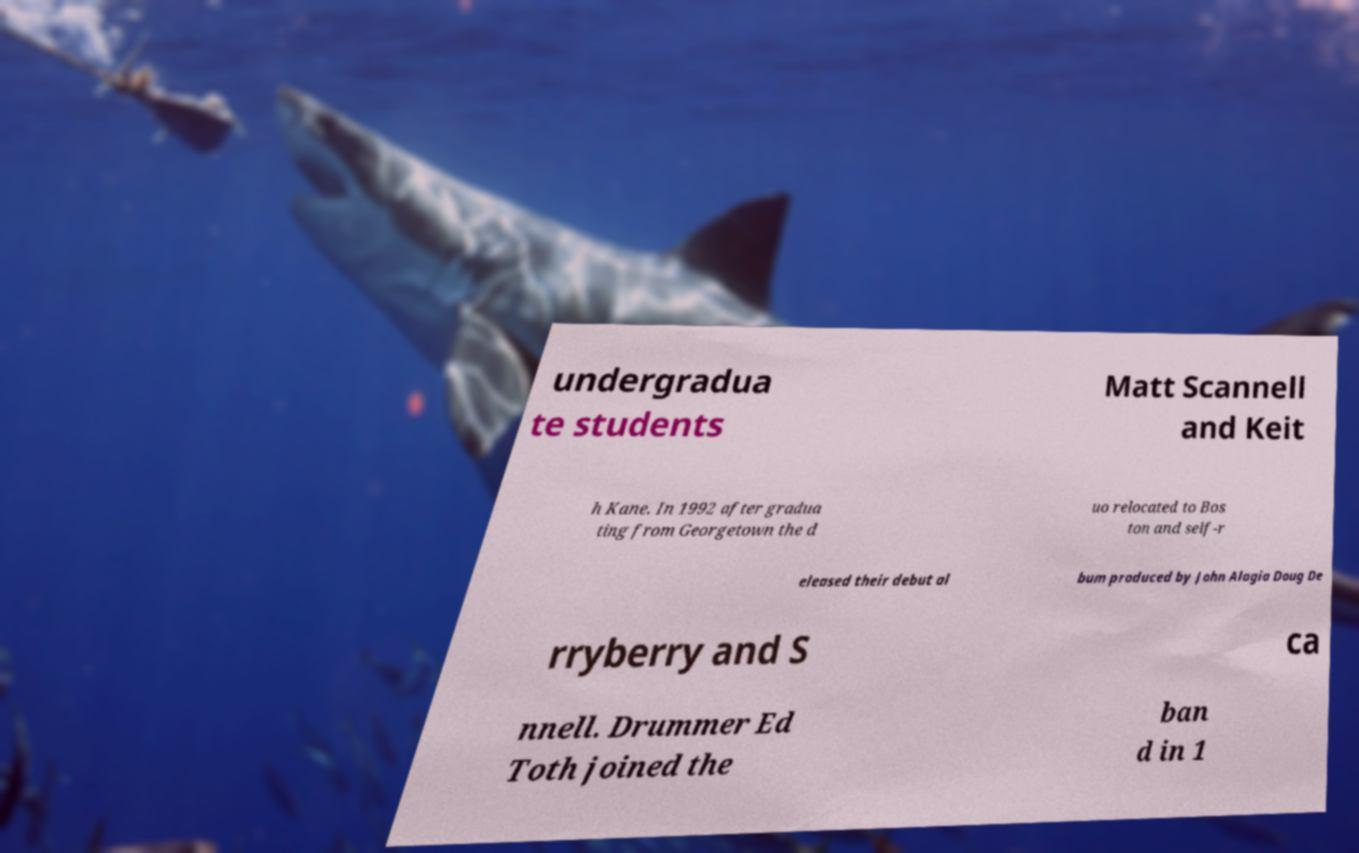Can you accurately transcribe the text from the provided image for me? undergradua te students Matt Scannell and Keit h Kane. In 1992 after gradua ting from Georgetown the d uo relocated to Bos ton and self-r eleased their debut al bum produced by John Alagia Doug De rryberry and S ca nnell. Drummer Ed Toth joined the ban d in 1 